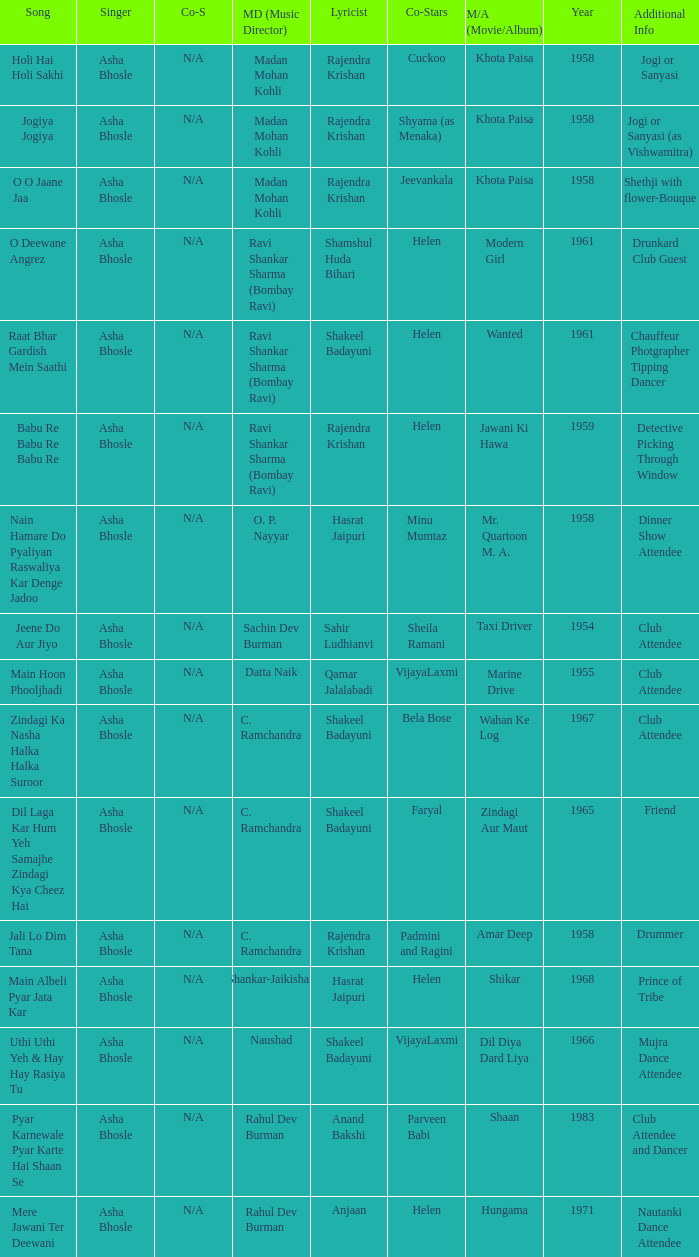Who sang for the movie Amar Deep? Asha Bhosle. 